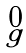<formula> <loc_0><loc_0><loc_500><loc_500>\begin{smallmatrix} 0 \\ g \end{smallmatrix}</formula> 